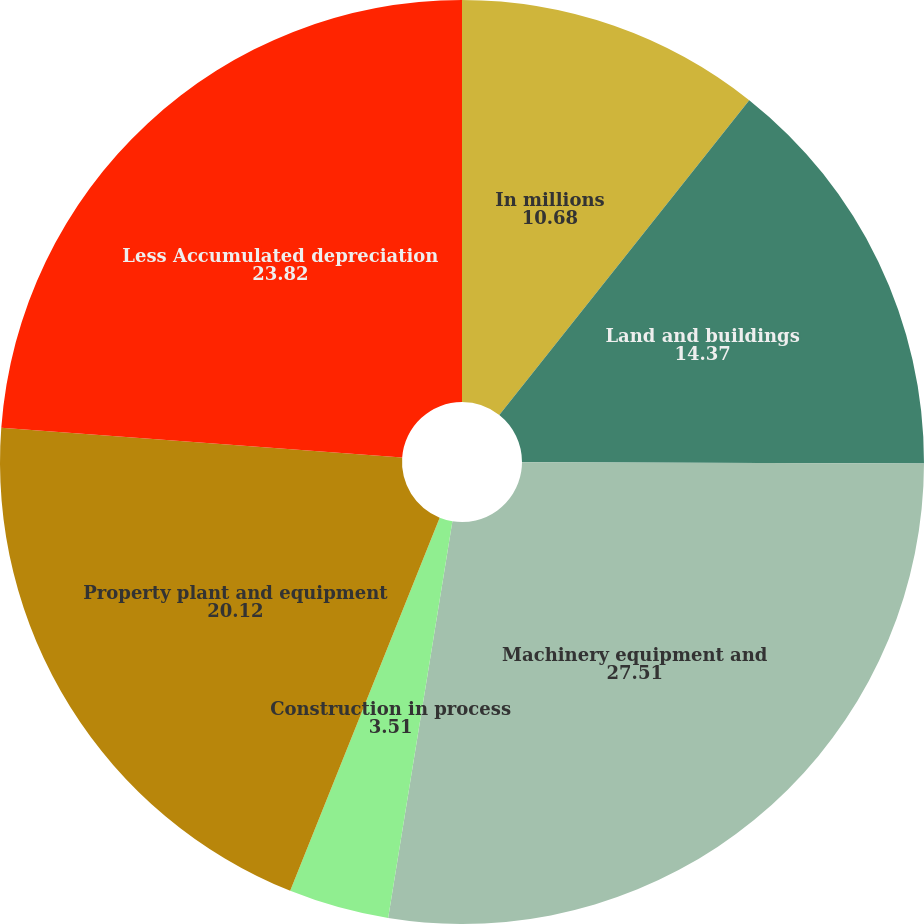<chart> <loc_0><loc_0><loc_500><loc_500><pie_chart><fcel>In millions<fcel>Land and buildings<fcel>Machinery equipment and<fcel>Construction in process<fcel>Property plant and equipment<fcel>Less Accumulated depreciation<nl><fcel>10.68%<fcel>14.37%<fcel>27.51%<fcel>3.51%<fcel>20.12%<fcel>23.82%<nl></chart> 